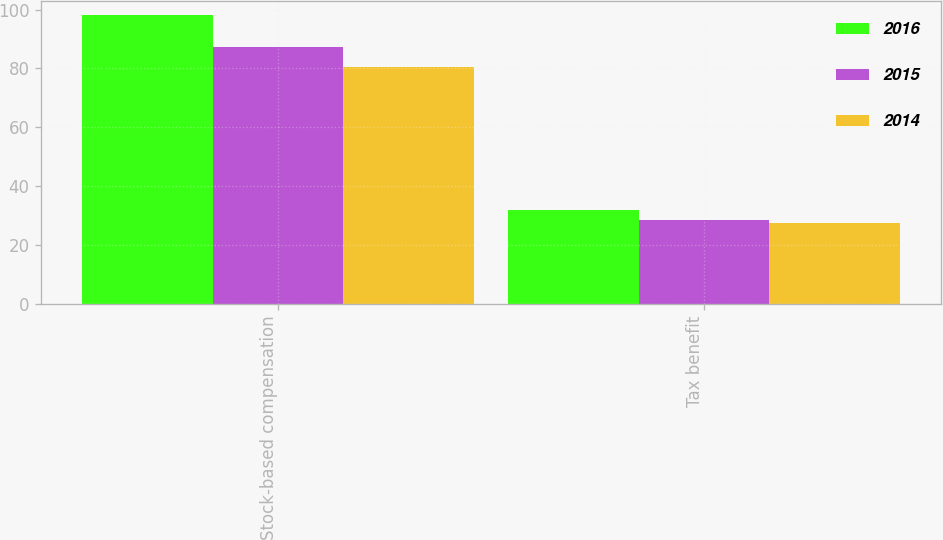Convert chart. <chart><loc_0><loc_0><loc_500><loc_500><stacked_bar_chart><ecel><fcel>Stock-based compensation<fcel>Tax benefit<nl><fcel>2016<fcel>98.1<fcel>31.9<nl><fcel>2015<fcel>87.2<fcel>28.6<nl><fcel>2014<fcel>80.4<fcel>27.5<nl></chart> 